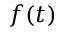Convert formula to latex. <formula><loc_0><loc_0><loc_500><loc_500>f ( t )</formula> 